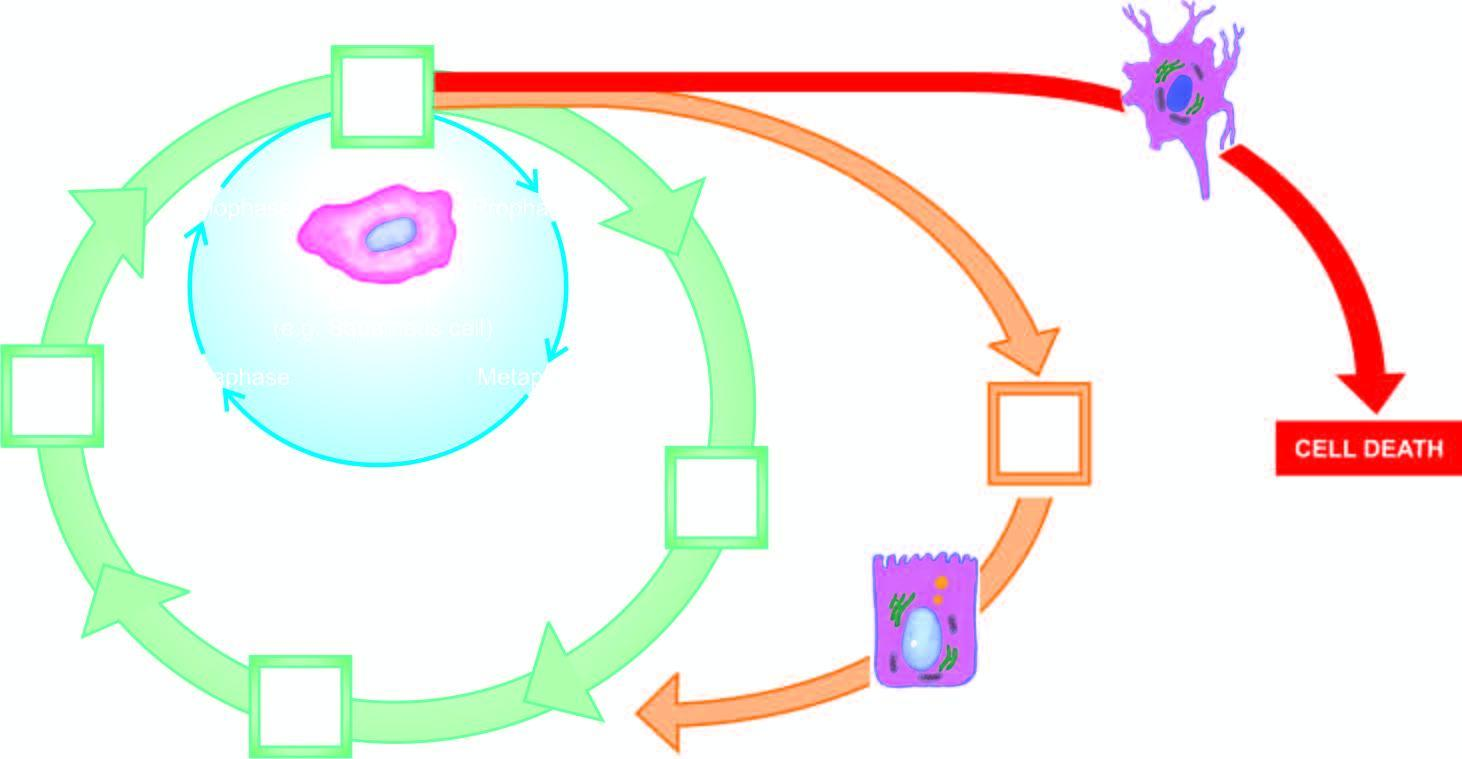does the circle shown with red line represent cell cycle for permanent cells?
Answer the question using a single word or phrase. Yes 